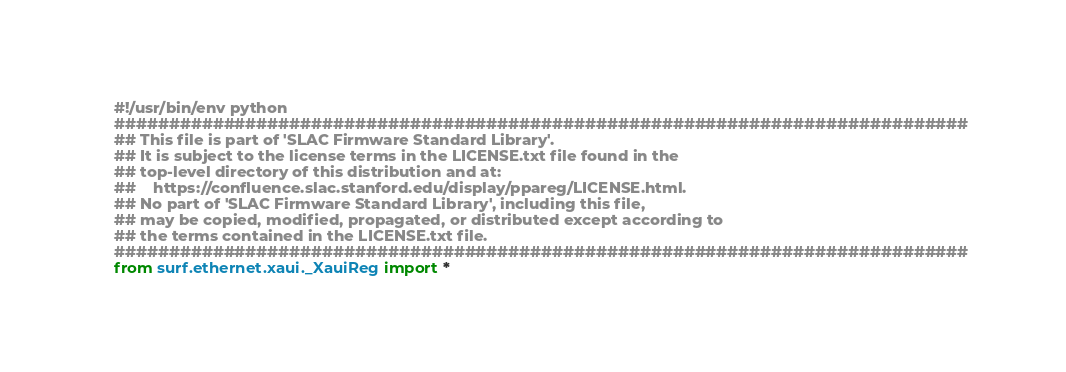<code> <loc_0><loc_0><loc_500><loc_500><_Python_>#!/usr/bin/env python
##############################################################################
## This file is part of 'SLAC Firmware Standard Library'.
## It is subject to the license terms in the LICENSE.txt file found in the 
## top-level directory of this distribution and at: 
##    https://confluence.slac.stanford.edu/display/ppareg/LICENSE.html. 
## No part of 'SLAC Firmware Standard Library', including this file, 
## may be copied, modified, propagated, or distributed except according to 
## the terms contained in the LICENSE.txt file.
##############################################################################
from surf.ethernet.xaui._XauiReg import *
</code> 